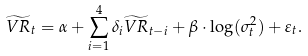<formula> <loc_0><loc_0><loc_500><loc_500>\widetilde { V R } _ { t } = \alpha + \sum _ { i = 1 } ^ { 4 } \delta _ { i } \widetilde { V R } _ { t - i } + \beta \cdot \log ( \sigma ^ { 2 } _ { t } ) + \varepsilon _ { t } .</formula> 